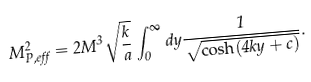Convert formula to latex. <formula><loc_0><loc_0><loc_500><loc_500>M ^ { 2 } _ { P , e f f } = 2 M ^ { 3 } \sqrt { \frac { k } { a } } \int _ { 0 } ^ { \infty } d y \frac { 1 } { \sqrt { \cosh ( 4 k y + c ) } } .</formula> 